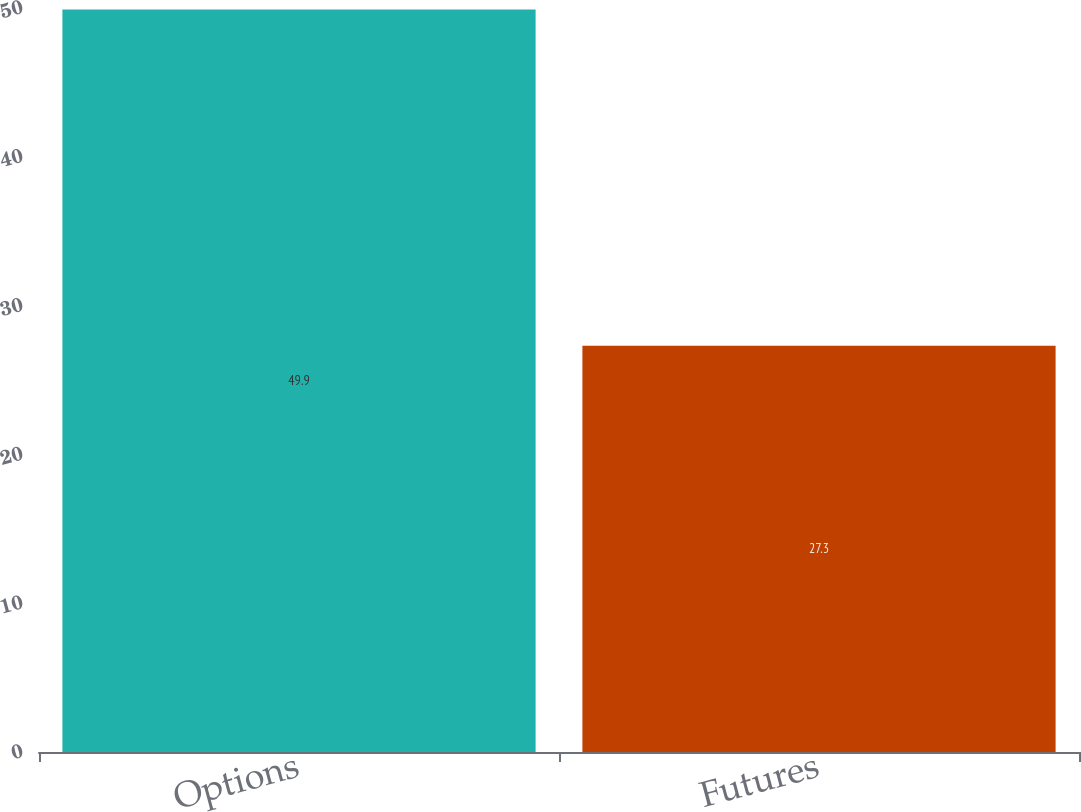Convert chart to OTSL. <chart><loc_0><loc_0><loc_500><loc_500><bar_chart><fcel>Options<fcel>Futures<nl><fcel>49.9<fcel>27.3<nl></chart> 